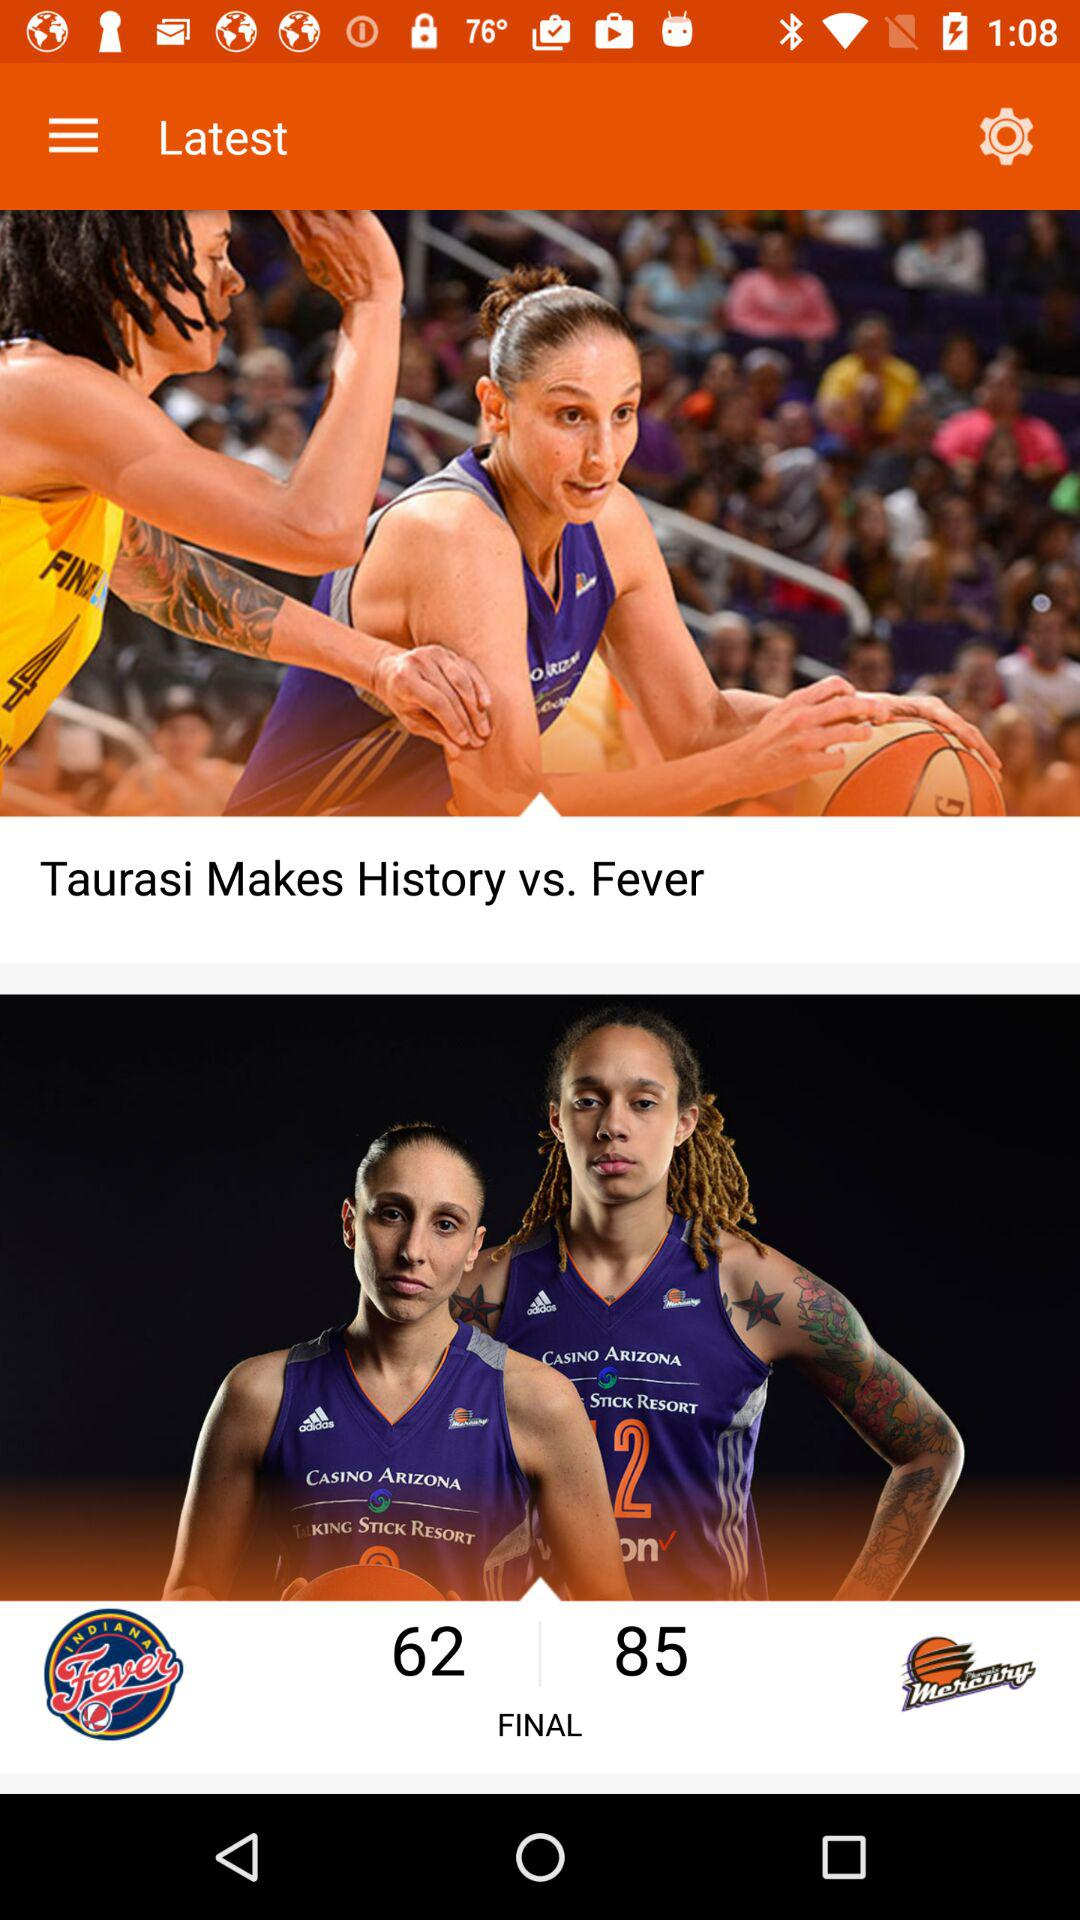Which are the two teams? The two teams are "Indiana Fever" and "Phoenix Mercury". 